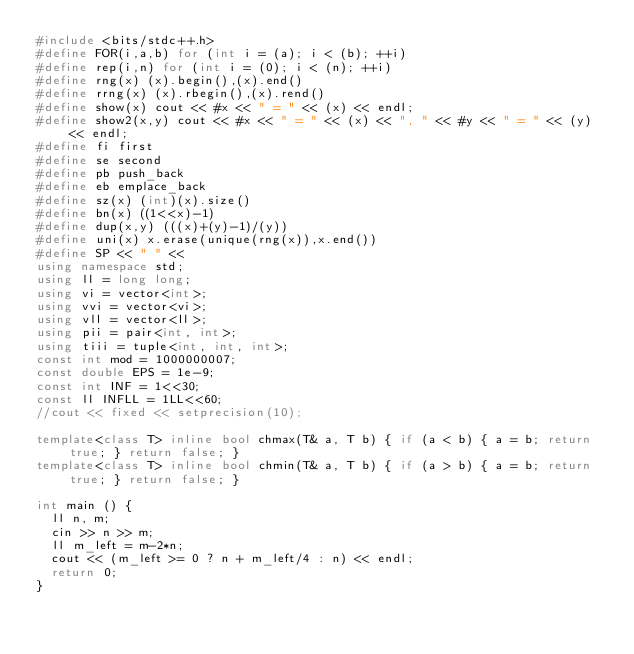<code> <loc_0><loc_0><loc_500><loc_500><_C++_>#include <bits/stdc++.h>
#define FOR(i,a,b) for (int i = (a); i < (b); ++i)
#define rep(i,n) for (int i = (0); i < (n); ++i)
#define rng(x) (x).begin(),(x).end()
#define rrng(x) (x).rbegin(),(x).rend()
#define show(x) cout << #x << " = " << (x) << endl;
#define show2(x,y) cout << #x << " = " << (x) << ", " << #y << " = " << (y) << endl;
#define fi first
#define se second
#define pb push_back
#define eb emplace_back
#define sz(x) (int)(x).size()
#define bn(x) ((1<<x)-1)
#define dup(x,y) (((x)+(y)-1)/(y))
#define uni(x) x.erase(unique(rng(x)),x.end())
#define SP << " " <<
using namespace std;
using ll = long long;
using vi = vector<int>;
using vvi = vector<vi>;
using vll = vector<ll>;
using pii = pair<int, int>;
using tiii = tuple<int, int, int>;
const int mod = 1000000007;
const double EPS = 1e-9;
const int INF = 1<<30;
const ll INFLL = 1LL<<60;
//cout << fixed << setprecision(10);

template<class T> inline bool chmax(T& a, T b) { if (a < b) { a = b; return true; } return false; }
template<class T> inline bool chmin(T& a, T b) { if (a > b) { a = b; return true; } return false; }

int main () {
  ll n, m;
  cin >> n >> m;
  ll m_left = m-2*n;
  cout << (m_left >= 0 ? n + m_left/4 : n) << endl;
  return 0;
}</code> 